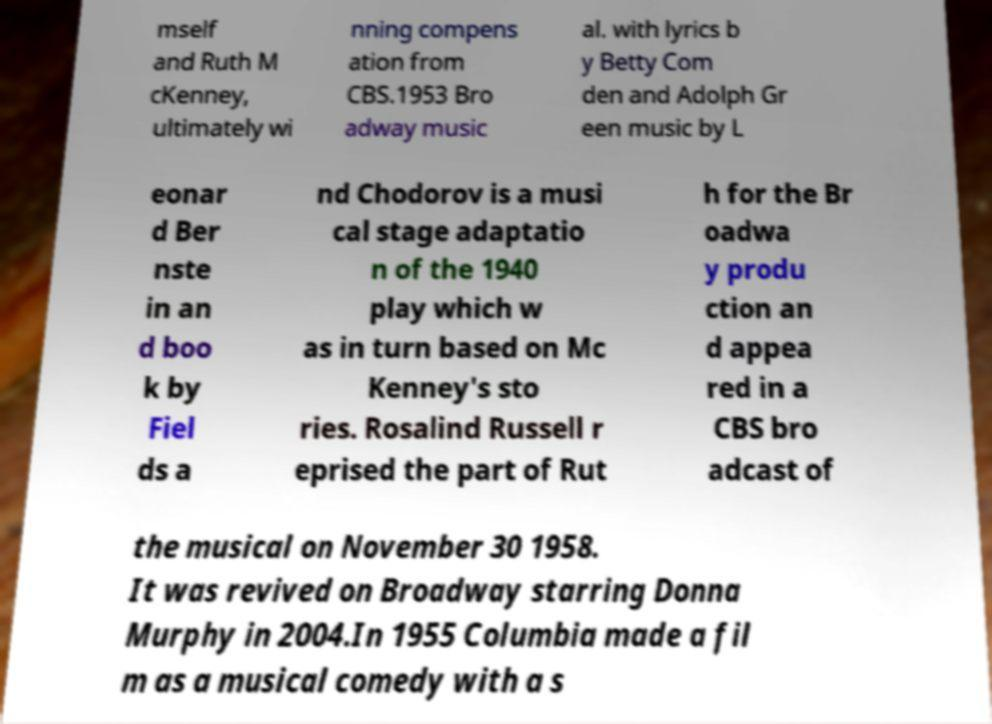Can you accurately transcribe the text from the provided image for me? mself and Ruth M cKenney, ultimately wi nning compens ation from CBS.1953 Bro adway music al. with lyrics b y Betty Com den and Adolph Gr een music by L eonar d Ber nste in an d boo k by Fiel ds a nd Chodorov is a musi cal stage adaptatio n of the 1940 play which w as in turn based on Mc Kenney's sto ries. Rosalind Russell r eprised the part of Rut h for the Br oadwa y produ ction an d appea red in a CBS bro adcast of the musical on November 30 1958. It was revived on Broadway starring Donna Murphy in 2004.In 1955 Columbia made a fil m as a musical comedy with a s 